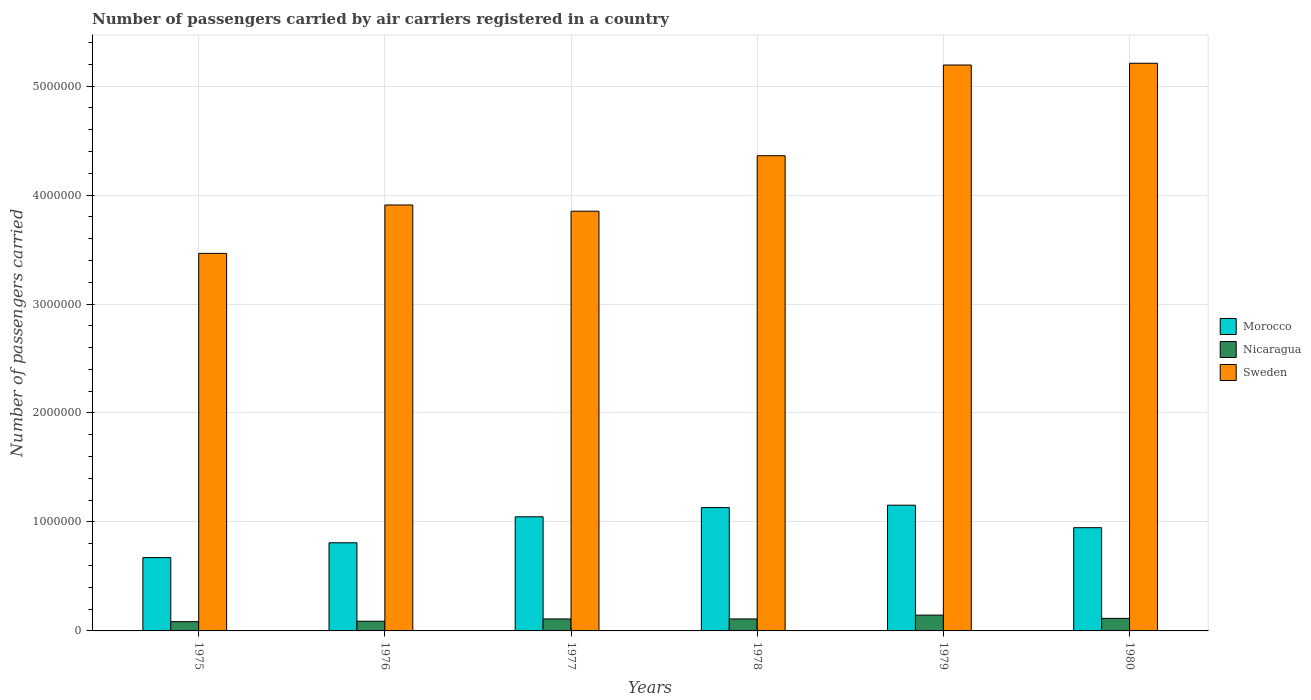How many different coloured bars are there?
Your answer should be very brief. 3. Are the number of bars per tick equal to the number of legend labels?
Offer a very short reply. Yes. Are the number of bars on each tick of the X-axis equal?
Your answer should be very brief. Yes. How many bars are there on the 6th tick from the left?
Offer a terse response. 3. What is the label of the 3rd group of bars from the left?
Give a very brief answer. 1977. In how many cases, is the number of bars for a given year not equal to the number of legend labels?
Provide a succinct answer. 0. What is the number of passengers carried by air carriers in Morocco in 1980?
Offer a terse response. 9.47e+05. Across all years, what is the maximum number of passengers carried by air carriers in Morocco?
Your answer should be compact. 1.15e+06. Across all years, what is the minimum number of passengers carried by air carriers in Morocco?
Ensure brevity in your answer.  6.73e+05. In which year was the number of passengers carried by air carriers in Morocco maximum?
Give a very brief answer. 1979. In which year was the number of passengers carried by air carriers in Morocco minimum?
Your answer should be compact. 1975. What is the total number of passengers carried by air carriers in Sweden in the graph?
Ensure brevity in your answer.  2.60e+07. What is the difference between the number of passengers carried by air carriers in Sweden in 1978 and that in 1980?
Your answer should be very brief. -8.48e+05. What is the difference between the number of passengers carried by air carriers in Sweden in 1977 and the number of passengers carried by air carriers in Morocco in 1976?
Your response must be concise. 3.04e+06. What is the average number of passengers carried by air carriers in Nicaragua per year?
Offer a terse response. 1.09e+05. In the year 1976, what is the difference between the number of passengers carried by air carriers in Sweden and number of passengers carried by air carriers in Morocco?
Keep it short and to the point. 3.10e+06. What is the ratio of the number of passengers carried by air carriers in Morocco in 1976 to that in 1977?
Ensure brevity in your answer.  0.77. What is the difference between the highest and the lowest number of passengers carried by air carriers in Sweden?
Your response must be concise. 1.74e+06. Is the sum of the number of passengers carried by air carriers in Nicaragua in 1975 and 1977 greater than the maximum number of passengers carried by air carriers in Morocco across all years?
Make the answer very short. No. What does the 2nd bar from the left in 1979 represents?
Ensure brevity in your answer.  Nicaragua. What does the 1st bar from the right in 1979 represents?
Ensure brevity in your answer.  Sweden. How many bars are there?
Your answer should be compact. 18. Are all the bars in the graph horizontal?
Give a very brief answer. No. How many years are there in the graph?
Make the answer very short. 6. Does the graph contain any zero values?
Keep it short and to the point. No. Does the graph contain grids?
Keep it short and to the point. Yes. Where does the legend appear in the graph?
Your answer should be compact. Center right. How many legend labels are there?
Make the answer very short. 3. How are the legend labels stacked?
Provide a succinct answer. Vertical. What is the title of the graph?
Offer a very short reply. Number of passengers carried by air carriers registered in a country. Does "Haiti" appear as one of the legend labels in the graph?
Your answer should be compact. No. What is the label or title of the Y-axis?
Your answer should be very brief. Number of passengers carried. What is the Number of passengers carried of Morocco in 1975?
Your answer should be compact. 6.73e+05. What is the Number of passengers carried of Nicaragua in 1975?
Offer a terse response. 8.50e+04. What is the Number of passengers carried of Sweden in 1975?
Keep it short and to the point. 3.46e+06. What is the Number of passengers carried of Morocco in 1976?
Your answer should be compact. 8.09e+05. What is the Number of passengers carried in Nicaragua in 1976?
Offer a terse response. 8.90e+04. What is the Number of passengers carried of Sweden in 1976?
Ensure brevity in your answer.  3.91e+06. What is the Number of passengers carried of Morocco in 1977?
Provide a short and direct response. 1.05e+06. What is the Number of passengers carried in Sweden in 1977?
Ensure brevity in your answer.  3.85e+06. What is the Number of passengers carried in Morocco in 1978?
Your response must be concise. 1.13e+06. What is the Number of passengers carried of Nicaragua in 1978?
Ensure brevity in your answer.  1.10e+05. What is the Number of passengers carried of Sweden in 1978?
Make the answer very short. 4.36e+06. What is the Number of passengers carried of Morocco in 1979?
Your response must be concise. 1.15e+06. What is the Number of passengers carried of Nicaragua in 1979?
Provide a succinct answer. 1.45e+05. What is the Number of passengers carried of Sweden in 1979?
Offer a terse response. 5.19e+06. What is the Number of passengers carried in Morocco in 1980?
Offer a terse response. 9.47e+05. What is the Number of passengers carried of Nicaragua in 1980?
Ensure brevity in your answer.  1.15e+05. What is the Number of passengers carried in Sweden in 1980?
Your answer should be very brief. 5.21e+06. Across all years, what is the maximum Number of passengers carried of Morocco?
Offer a terse response. 1.15e+06. Across all years, what is the maximum Number of passengers carried of Nicaragua?
Make the answer very short. 1.45e+05. Across all years, what is the maximum Number of passengers carried of Sweden?
Ensure brevity in your answer.  5.21e+06. Across all years, what is the minimum Number of passengers carried in Morocco?
Give a very brief answer. 6.73e+05. Across all years, what is the minimum Number of passengers carried of Nicaragua?
Provide a succinct answer. 8.50e+04. Across all years, what is the minimum Number of passengers carried of Sweden?
Give a very brief answer. 3.46e+06. What is the total Number of passengers carried of Morocco in the graph?
Your response must be concise. 5.76e+06. What is the total Number of passengers carried of Nicaragua in the graph?
Your response must be concise. 6.54e+05. What is the total Number of passengers carried in Sweden in the graph?
Keep it short and to the point. 2.60e+07. What is the difference between the Number of passengers carried in Morocco in 1975 and that in 1976?
Make the answer very short. -1.36e+05. What is the difference between the Number of passengers carried of Nicaragua in 1975 and that in 1976?
Provide a succinct answer. -4000. What is the difference between the Number of passengers carried in Sweden in 1975 and that in 1976?
Make the answer very short. -4.44e+05. What is the difference between the Number of passengers carried in Morocco in 1975 and that in 1977?
Provide a short and direct response. -3.74e+05. What is the difference between the Number of passengers carried of Nicaragua in 1975 and that in 1977?
Offer a terse response. -2.50e+04. What is the difference between the Number of passengers carried of Sweden in 1975 and that in 1977?
Give a very brief answer. -3.87e+05. What is the difference between the Number of passengers carried of Morocco in 1975 and that in 1978?
Provide a short and direct response. -4.59e+05. What is the difference between the Number of passengers carried in Nicaragua in 1975 and that in 1978?
Provide a short and direct response. -2.50e+04. What is the difference between the Number of passengers carried of Sweden in 1975 and that in 1978?
Offer a terse response. -8.96e+05. What is the difference between the Number of passengers carried in Morocco in 1975 and that in 1979?
Offer a very short reply. -4.81e+05. What is the difference between the Number of passengers carried in Nicaragua in 1975 and that in 1979?
Offer a terse response. -6.00e+04. What is the difference between the Number of passengers carried in Sweden in 1975 and that in 1979?
Keep it short and to the point. -1.73e+06. What is the difference between the Number of passengers carried of Morocco in 1975 and that in 1980?
Offer a very short reply. -2.74e+05. What is the difference between the Number of passengers carried of Nicaragua in 1975 and that in 1980?
Offer a very short reply. -3.00e+04. What is the difference between the Number of passengers carried in Sweden in 1975 and that in 1980?
Your answer should be very brief. -1.74e+06. What is the difference between the Number of passengers carried of Morocco in 1976 and that in 1977?
Give a very brief answer. -2.38e+05. What is the difference between the Number of passengers carried of Nicaragua in 1976 and that in 1977?
Ensure brevity in your answer.  -2.10e+04. What is the difference between the Number of passengers carried in Sweden in 1976 and that in 1977?
Provide a succinct answer. 5.71e+04. What is the difference between the Number of passengers carried in Morocco in 1976 and that in 1978?
Make the answer very short. -3.23e+05. What is the difference between the Number of passengers carried of Nicaragua in 1976 and that in 1978?
Offer a terse response. -2.10e+04. What is the difference between the Number of passengers carried in Sweden in 1976 and that in 1978?
Make the answer very short. -4.52e+05. What is the difference between the Number of passengers carried in Morocco in 1976 and that in 1979?
Offer a terse response. -3.45e+05. What is the difference between the Number of passengers carried of Nicaragua in 1976 and that in 1979?
Ensure brevity in your answer.  -5.60e+04. What is the difference between the Number of passengers carried in Sweden in 1976 and that in 1979?
Your response must be concise. -1.28e+06. What is the difference between the Number of passengers carried in Morocco in 1976 and that in 1980?
Offer a terse response. -1.38e+05. What is the difference between the Number of passengers carried in Nicaragua in 1976 and that in 1980?
Give a very brief answer. -2.60e+04. What is the difference between the Number of passengers carried of Sweden in 1976 and that in 1980?
Your answer should be very brief. -1.30e+06. What is the difference between the Number of passengers carried in Morocco in 1977 and that in 1978?
Your response must be concise. -8.45e+04. What is the difference between the Number of passengers carried of Sweden in 1977 and that in 1978?
Your response must be concise. -5.09e+05. What is the difference between the Number of passengers carried of Morocco in 1977 and that in 1979?
Provide a succinct answer. -1.07e+05. What is the difference between the Number of passengers carried of Nicaragua in 1977 and that in 1979?
Your answer should be compact. -3.50e+04. What is the difference between the Number of passengers carried of Sweden in 1977 and that in 1979?
Provide a succinct answer. -1.34e+06. What is the difference between the Number of passengers carried of Morocco in 1977 and that in 1980?
Keep it short and to the point. 9.98e+04. What is the difference between the Number of passengers carried of Nicaragua in 1977 and that in 1980?
Give a very brief answer. -5000. What is the difference between the Number of passengers carried in Sweden in 1977 and that in 1980?
Your answer should be very brief. -1.36e+06. What is the difference between the Number of passengers carried of Morocco in 1978 and that in 1979?
Your answer should be very brief. -2.21e+04. What is the difference between the Number of passengers carried in Nicaragua in 1978 and that in 1979?
Make the answer very short. -3.50e+04. What is the difference between the Number of passengers carried in Sweden in 1978 and that in 1979?
Offer a terse response. -8.32e+05. What is the difference between the Number of passengers carried of Morocco in 1978 and that in 1980?
Your response must be concise. 1.84e+05. What is the difference between the Number of passengers carried of Nicaragua in 1978 and that in 1980?
Make the answer very short. -5000. What is the difference between the Number of passengers carried in Sweden in 1978 and that in 1980?
Your response must be concise. -8.48e+05. What is the difference between the Number of passengers carried in Morocco in 1979 and that in 1980?
Provide a short and direct response. 2.06e+05. What is the difference between the Number of passengers carried of Sweden in 1979 and that in 1980?
Your answer should be compact. -1.60e+04. What is the difference between the Number of passengers carried of Morocco in 1975 and the Number of passengers carried of Nicaragua in 1976?
Your answer should be very brief. 5.84e+05. What is the difference between the Number of passengers carried in Morocco in 1975 and the Number of passengers carried in Sweden in 1976?
Your answer should be compact. -3.24e+06. What is the difference between the Number of passengers carried in Nicaragua in 1975 and the Number of passengers carried in Sweden in 1976?
Provide a succinct answer. -3.82e+06. What is the difference between the Number of passengers carried of Morocco in 1975 and the Number of passengers carried of Nicaragua in 1977?
Provide a succinct answer. 5.63e+05. What is the difference between the Number of passengers carried in Morocco in 1975 and the Number of passengers carried in Sweden in 1977?
Your answer should be compact. -3.18e+06. What is the difference between the Number of passengers carried of Nicaragua in 1975 and the Number of passengers carried of Sweden in 1977?
Make the answer very short. -3.77e+06. What is the difference between the Number of passengers carried of Morocco in 1975 and the Number of passengers carried of Nicaragua in 1978?
Ensure brevity in your answer.  5.63e+05. What is the difference between the Number of passengers carried of Morocco in 1975 and the Number of passengers carried of Sweden in 1978?
Keep it short and to the point. -3.69e+06. What is the difference between the Number of passengers carried of Nicaragua in 1975 and the Number of passengers carried of Sweden in 1978?
Your answer should be compact. -4.28e+06. What is the difference between the Number of passengers carried in Morocco in 1975 and the Number of passengers carried in Nicaragua in 1979?
Offer a very short reply. 5.28e+05. What is the difference between the Number of passengers carried of Morocco in 1975 and the Number of passengers carried of Sweden in 1979?
Your response must be concise. -4.52e+06. What is the difference between the Number of passengers carried of Nicaragua in 1975 and the Number of passengers carried of Sweden in 1979?
Offer a terse response. -5.11e+06. What is the difference between the Number of passengers carried of Morocco in 1975 and the Number of passengers carried of Nicaragua in 1980?
Ensure brevity in your answer.  5.58e+05. What is the difference between the Number of passengers carried of Morocco in 1975 and the Number of passengers carried of Sweden in 1980?
Make the answer very short. -4.54e+06. What is the difference between the Number of passengers carried in Nicaragua in 1975 and the Number of passengers carried in Sweden in 1980?
Your response must be concise. -5.12e+06. What is the difference between the Number of passengers carried of Morocco in 1976 and the Number of passengers carried of Nicaragua in 1977?
Make the answer very short. 6.99e+05. What is the difference between the Number of passengers carried of Morocco in 1976 and the Number of passengers carried of Sweden in 1977?
Make the answer very short. -3.04e+06. What is the difference between the Number of passengers carried in Nicaragua in 1976 and the Number of passengers carried in Sweden in 1977?
Make the answer very short. -3.76e+06. What is the difference between the Number of passengers carried in Morocco in 1976 and the Number of passengers carried in Nicaragua in 1978?
Your answer should be compact. 6.99e+05. What is the difference between the Number of passengers carried in Morocco in 1976 and the Number of passengers carried in Sweden in 1978?
Offer a terse response. -3.55e+06. What is the difference between the Number of passengers carried of Nicaragua in 1976 and the Number of passengers carried of Sweden in 1978?
Give a very brief answer. -4.27e+06. What is the difference between the Number of passengers carried of Morocco in 1976 and the Number of passengers carried of Nicaragua in 1979?
Provide a short and direct response. 6.64e+05. What is the difference between the Number of passengers carried in Morocco in 1976 and the Number of passengers carried in Sweden in 1979?
Keep it short and to the point. -4.38e+06. What is the difference between the Number of passengers carried of Nicaragua in 1976 and the Number of passengers carried of Sweden in 1979?
Offer a very short reply. -5.10e+06. What is the difference between the Number of passengers carried of Morocco in 1976 and the Number of passengers carried of Nicaragua in 1980?
Ensure brevity in your answer.  6.94e+05. What is the difference between the Number of passengers carried of Morocco in 1976 and the Number of passengers carried of Sweden in 1980?
Your answer should be compact. -4.40e+06. What is the difference between the Number of passengers carried of Nicaragua in 1976 and the Number of passengers carried of Sweden in 1980?
Offer a terse response. -5.12e+06. What is the difference between the Number of passengers carried in Morocco in 1977 and the Number of passengers carried in Nicaragua in 1978?
Provide a short and direct response. 9.37e+05. What is the difference between the Number of passengers carried in Morocco in 1977 and the Number of passengers carried in Sweden in 1978?
Offer a very short reply. -3.31e+06. What is the difference between the Number of passengers carried in Nicaragua in 1977 and the Number of passengers carried in Sweden in 1978?
Your answer should be compact. -4.25e+06. What is the difference between the Number of passengers carried of Morocco in 1977 and the Number of passengers carried of Nicaragua in 1979?
Keep it short and to the point. 9.02e+05. What is the difference between the Number of passengers carried in Morocco in 1977 and the Number of passengers carried in Sweden in 1979?
Provide a succinct answer. -4.15e+06. What is the difference between the Number of passengers carried in Nicaragua in 1977 and the Number of passengers carried in Sweden in 1979?
Make the answer very short. -5.08e+06. What is the difference between the Number of passengers carried in Morocco in 1977 and the Number of passengers carried in Nicaragua in 1980?
Keep it short and to the point. 9.32e+05. What is the difference between the Number of passengers carried of Morocco in 1977 and the Number of passengers carried of Sweden in 1980?
Your answer should be very brief. -4.16e+06. What is the difference between the Number of passengers carried in Nicaragua in 1977 and the Number of passengers carried in Sweden in 1980?
Your response must be concise. -5.10e+06. What is the difference between the Number of passengers carried of Morocco in 1978 and the Number of passengers carried of Nicaragua in 1979?
Your response must be concise. 9.87e+05. What is the difference between the Number of passengers carried of Morocco in 1978 and the Number of passengers carried of Sweden in 1979?
Give a very brief answer. -4.06e+06. What is the difference between the Number of passengers carried in Nicaragua in 1978 and the Number of passengers carried in Sweden in 1979?
Your response must be concise. -5.08e+06. What is the difference between the Number of passengers carried in Morocco in 1978 and the Number of passengers carried in Nicaragua in 1980?
Your answer should be compact. 1.02e+06. What is the difference between the Number of passengers carried in Morocco in 1978 and the Number of passengers carried in Sweden in 1980?
Your answer should be very brief. -4.08e+06. What is the difference between the Number of passengers carried in Nicaragua in 1978 and the Number of passengers carried in Sweden in 1980?
Provide a short and direct response. -5.10e+06. What is the difference between the Number of passengers carried of Morocco in 1979 and the Number of passengers carried of Nicaragua in 1980?
Provide a short and direct response. 1.04e+06. What is the difference between the Number of passengers carried of Morocco in 1979 and the Number of passengers carried of Sweden in 1980?
Provide a succinct answer. -4.06e+06. What is the difference between the Number of passengers carried of Nicaragua in 1979 and the Number of passengers carried of Sweden in 1980?
Keep it short and to the point. -5.06e+06. What is the average Number of passengers carried of Morocco per year?
Ensure brevity in your answer.  9.60e+05. What is the average Number of passengers carried of Nicaragua per year?
Your answer should be very brief. 1.09e+05. What is the average Number of passengers carried of Sweden per year?
Your response must be concise. 4.33e+06. In the year 1975, what is the difference between the Number of passengers carried in Morocco and Number of passengers carried in Nicaragua?
Ensure brevity in your answer.  5.88e+05. In the year 1975, what is the difference between the Number of passengers carried of Morocco and Number of passengers carried of Sweden?
Your answer should be compact. -2.79e+06. In the year 1975, what is the difference between the Number of passengers carried of Nicaragua and Number of passengers carried of Sweden?
Provide a short and direct response. -3.38e+06. In the year 1976, what is the difference between the Number of passengers carried in Morocco and Number of passengers carried in Nicaragua?
Your response must be concise. 7.20e+05. In the year 1976, what is the difference between the Number of passengers carried in Morocco and Number of passengers carried in Sweden?
Ensure brevity in your answer.  -3.10e+06. In the year 1976, what is the difference between the Number of passengers carried in Nicaragua and Number of passengers carried in Sweden?
Make the answer very short. -3.82e+06. In the year 1977, what is the difference between the Number of passengers carried in Morocco and Number of passengers carried in Nicaragua?
Offer a terse response. 9.37e+05. In the year 1977, what is the difference between the Number of passengers carried of Morocco and Number of passengers carried of Sweden?
Your response must be concise. -2.80e+06. In the year 1977, what is the difference between the Number of passengers carried in Nicaragua and Number of passengers carried in Sweden?
Provide a succinct answer. -3.74e+06. In the year 1978, what is the difference between the Number of passengers carried of Morocco and Number of passengers carried of Nicaragua?
Offer a very short reply. 1.02e+06. In the year 1978, what is the difference between the Number of passengers carried in Morocco and Number of passengers carried in Sweden?
Ensure brevity in your answer.  -3.23e+06. In the year 1978, what is the difference between the Number of passengers carried of Nicaragua and Number of passengers carried of Sweden?
Offer a terse response. -4.25e+06. In the year 1979, what is the difference between the Number of passengers carried of Morocco and Number of passengers carried of Nicaragua?
Your response must be concise. 1.01e+06. In the year 1979, what is the difference between the Number of passengers carried in Morocco and Number of passengers carried in Sweden?
Provide a short and direct response. -4.04e+06. In the year 1979, what is the difference between the Number of passengers carried of Nicaragua and Number of passengers carried of Sweden?
Give a very brief answer. -5.05e+06. In the year 1980, what is the difference between the Number of passengers carried of Morocco and Number of passengers carried of Nicaragua?
Your answer should be very brief. 8.32e+05. In the year 1980, what is the difference between the Number of passengers carried of Morocco and Number of passengers carried of Sweden?
Provide a succinct answer. -4.26e+06. In the year 1980, what is the difference between the Number of passengers carried of Nicaragua and Number of passengers carried of Sweden?
Your answer should be compact. -5.09e+06. What is the ratio of the Number of passengers carried in Morocco in 1975 to that in 1976?
Provide a succinct answer. 0.83. What is the ratio of the Number of passengers carried in Nicaragua in 1975 to that in 1976?
Offer a very short reply. 0.96. What is the ratio of the Number of passengers carried of Sweden in 1975 to that in 1976?
Ensure brevity in your answer.  0.89. What is the ratio of the Number of passengers carried of Morocco in 1975 to that in 1977?
Your response must be concise. 0.64. What is the ratio of the Number of passengers carried in Nicaragua in 1975 to that in 1977?
Provide a succinct answer. 0.77. What is the ratio of the Number of passengers carried in Sweden in 1975 to that in 1977?
Offer a terse response. 0.9. What is the ratio of the Number of passengers carried of Morocco in 1975 to that in 1978?
Make the answer very short. 0.59. What is the ratio of the Number of passengers carried in Nicaragua in 1975 to that in 1978?
Provide a succinct answer. 0.77. What is the ratio of the Number of passengers carried in Sweden in 1975 to that in 1978?
Your answer should be very brief. 0.79. What is the ratio of the Number of passengers carried in Morocco in 1975 to that in 1979?
Your answer should be very brief. 0.58. What is the ratio of the Number of passengers carried of Nicaragua in 1975 to that in 1979?
Provide a short and direct response. 0.59. What is the ratio of the Number of passengers carried in Sweden in 1975 to that in 1979?
Your answer should be compact. 0.67. What is the ratio of the Number of passengers carried of Morocco in 1975 to that in 1980?
Your answer should be very brief. 0.71. What is the ratio of the Number of passengers carried of Nicaragua in 1975 to that in 1980?
Ensure brevity in your answer.  0.74. What is the ratio of the Number of passengers carried in Sweden in 1975 to that in 1980?
Offer a very short reply. 0.67. What is the ratio of the Number of passengers carried in Morocco in 1976 to that in 1977?
Your answer should be compact. 0.77. What is the ratio of the Number of passengers carried of Nicaragua in 1976 to that in 1977?
Your response must be concise. 0.81. What is the ratio of the Number of passengers carried in Sweden in 1976 to that in 1977?
Offer a terse response. 1.01. What is the ratio of the Number of passengers carried of Morocco in 1976 to that in 1978?
Keep it short and to the point. 0.71. What is the ratio of the Number of passengers carried in Nicaragua in 1976 to that in 1978?
Provide a succinct answer. 0.81. What is the ratio of the Number of passengers carried of Sweden in 1976 to that in 1978?
Your answer should be very brief. 0.9. What is the ratio of the Number of passengers carried of Morocco in 1976 to that in 1979?
Ensure brevity in your answer.  0.7. What is the ratio of the Number of passengers carried in Nicaragua in 1976 to that in 1979?
Make the answer very short. 0.61. What is the ratio of the Number of passengers carried of Sweden in 1976 to that in 1979?
Offer a very short reply. 0.75. What is the ratio of the Number of passengers carried of Morocco in 1976 to that in 1980?
Provide a succinct answer. 0.85. What is the ratio of the Number of passengers carried in Nicaragua in 1976 to that in 1980?
Offer a terse response. 0.77. What is the ratio of the Number of passengers carried of Sweden in 1976 to that in 1980?
Offer a very short reply. 0.75. What is the ratio of the Number of passengers carried in Morocco in 1977 to that in 1978?
Your answer should be very brief. 0.93. What is the ratio of the Number of passengers carried in Sweden in 1977 to that in 1978?
Offer a very short reply. 0.88. What is the ratio of the Number of passengers carried of Morocco in 1977 to that in 1979?
Provide a succinct answer. 0.91. What is the ratio of the Number of passengers carried in Nicaragua in 1977 to that in 1979?
Offer a very short reply. 0.76. What is the ratio of the Number of passengers carried of Sweden in 1977 to that in 1979?
Provide a short and direct response. 0.74. What is the ratio of the Number of passengers carried of Morocco in 1977 to that in 1980?
Your answer should be compact. 1.11. What is the ratio of the Number of passengers carried of Nicaragua in 1977 to that in 1980?
Keep it short and to the point. 0.96. What is the ratio of the Number of passengers carried in Sweden in 1977 to that in 1980?
Offer a terse response. 0.74. What is the ratio of the Number of passengers carried of Morocco in 1978 to that in 1979?
Offer a very short reply. 0.98. What is the ratio of the Number of passengers carried in Nicaragua in 1978 to that in 1979?
Your answer should be compact. 0.76. What is the ratio of the Number of passengers carried in Sweden in 1978 to that in 1979?
Offer a terse response. 0.84. What is the ratio of the Number of passengers carried in Morocco in 1978 to that in 1980?
Offer a very short reply. 1.19. What is the ratio of the Number of passengers carried of Nicaragua in 1978 to that in 1980?
Offer a terse response. 0.96. What is the ratio of the Number of passengers carried of Sweden in 1978 to that in 1980?
Keep it short and to the point. 0.84. What is the ratio of the Number of passengers carried in Morocco in 1979 to that in 1980?
Give a very brief answer. 1.22. What is the ratio of the Number of passengers carried in Nicaragua in 1979 to that in 1980?
Provide a short and direct response. 1.26. What is the difference between the highest and the second highest Number of passengers carried in Morocco?
Provide a succinct answer. 2.21e+04. What is the difference between the highest and the second highest Number of passengers carried in Sweden?
Give a very brief answer. 1.60e+04. What is the difference between the highest and the lowest Number of passengers carried of Morocco?
Your answer should be very brief. 4.81e+05. What is the difference between the highest and the lowest Number of passengers carried in Sweden?
Give a very brief answer. 1.74e+06. 